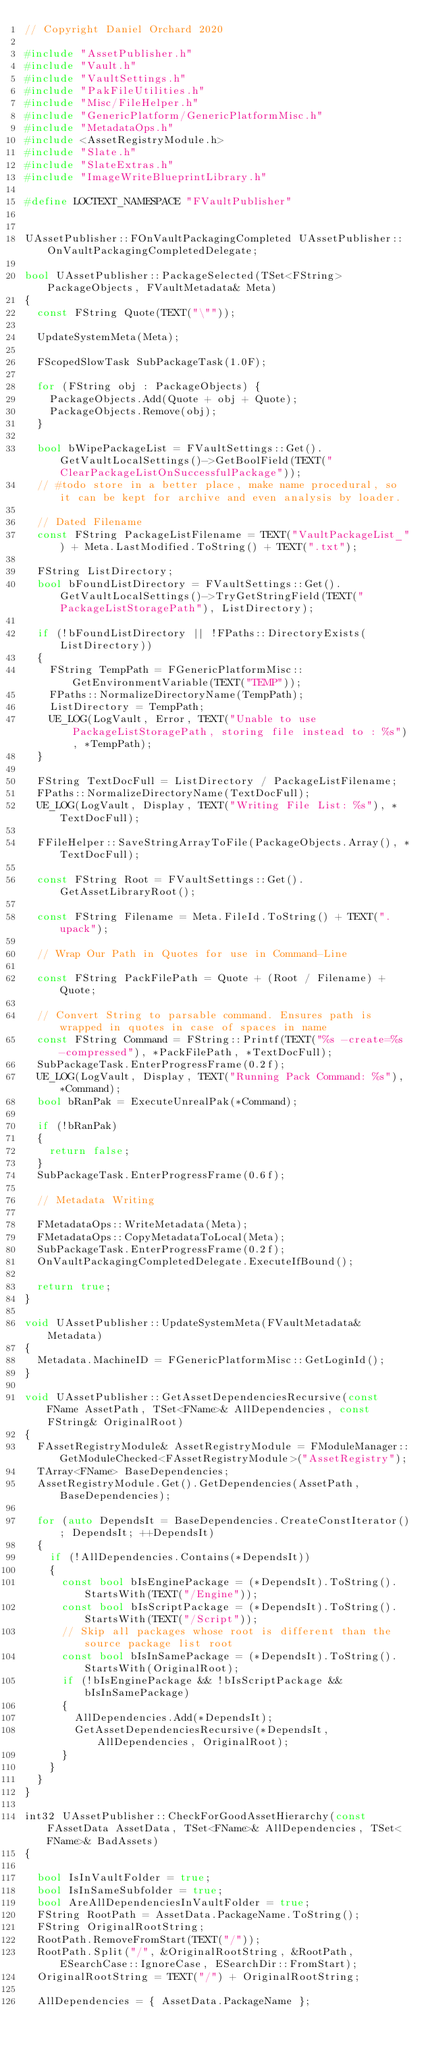<code> <loc_0><loc_0><loc_500><loc_500><_C++_>// Copyright Daniel Orchard 2020

#include "AssetPublisher.h"
#include "Vault.h"
#include "VaultSettings.h"
#include "PakFileUtilities.h"
#include "Misc/FileHelper.h"
#include "GenericPlatform/GenericPlatformMisc.h"
#include "MetadataOps.h"
#include <AssetRegistryModule.h>
#include "Slate.h"
#include "SlateExtras.h"
#include "ImageWriteBlueprintLibrary.h"

#define LOCTEXT_NAMESPACE "FVaultPublisher"


UAssetPublisher::FOnVaultPackagingCompleted UAssetPublisher::OnVaultPackagingCompletedDelegate;

bool UAssetPublisher::PackageSelected(TSet<FString> PackageObjects, FVaultMetadata& Meta)
{
	const FString Quote(TEXT("\""));

	UpdateSystemMeta(Meta);

	FScopedSlowTask SubPackageTask(1.0F);

	for (FString obj : PackageObjects) {
		PackageObjects.Add(Quote + obj + Quote);
		PackageObjects.Remove(obj);
	}

	bool bWipePackageList = FVaultSettings::Get().GetVaultLocalSettings()->GetBoolField(TEXT("ClearPackageListOnSuccessfulPackage"));
	// #todo store in a better place, make name procedural, so it can be kept for archive and even analysis by loader.

	// Dated Filename
	const FString PackageListFilename = TEXT("VaultPackageList_") + Meta.LastModified.ToString() + TEXT(".txt");

	FString ListDirectory;
	bool bFoundListDirectory = FVaultSettings::Get().GetVaultLocalSettings()->TryGetStringField(TEXT("PackageListStoragePath"), ListDirectory);

	if (!bFoundListDirectory || !FPaths::DirectoryExists(ListDirectory))
	{
		FString TempPath = FGenericPlatformMisc::GetEnvironmentVariable(TEXT("TEMP"));
		FPaths::NormalizeDirectoryName(TempPath);
		ListDirectory = TempPath;
		UE_LOG(LogVault, Error, TEXT("Unable to use PackageListStoragePath, storing file instead to : %s"), *TempPath);
	}

	FString TextDocFull = ListDirectory / PackageListFilename;
	FPaths::NormalizeDirectoryName(TextDocFull);
	UE_LOG(LogVault, Display, TEXT("Writing File List: %s"), *TextDocFull);
	
	FFileHelper::SaveStringArrayToFile(PackageObjects.Array(), *TextDocFull);
	
	const FString Root = FVaultSettings::Get().GetAssetLibraryRoot();
	
	const FString Filename = Meta.FileId.ToString() + TEXT(".upack");

	// Wrap Our Path in Quotes for use in Command-Line
	
	const FString PackFilePath = Quote + (Root / Filename) + Quote;
	
	// Convert String to parsable command. Ensures path is wrapped in quotes in case of spaces in name
	const FString Command = FString::Printf(TEXT("%s -create=%s -compressed"), *PackFilePath, *TextDocFull);
	SubPackageTask.EnterProgressFrame(0.2f);
	UE_LOG(LogVault, Display, TEXT("Running Pack Command: %s"), *Command);
	bool bRanPak = ExecuteUnrealPak(*Command);

	if (!bRanPak)
	{
		return false;
	}
	SubPackageTask.EnterProgressFrame(0.6f);

	// Metadata Writing

	FMetadataOps::WriteMetadata(Meta);
	FMetadataOps::CopyMetadataToLocal(Meta);
	SubPackageTask.EnterProgressFrame(0.2f);
	OnVaultPackagingCompletedDelegate.ExecuteIfBound();

	return true;
}

void UAssetPublisher::UpdateSystemMeta(FVaultMetadata& Metadata)
{
	Metadata.MachineID = FGenericPlatformMisc::GetLoginId();
}

void UAssetPublisher::GetAssetDependenciesRecursive(const FName AssetPath, TSet<FName>& AllDependencies, const FString& OriginalRoot)
{
	FAssetRegistryModule& AssetRegistryModule = FModuleManager::GetModuleChecked<FAssetRegistryModule>("AssetRegistry");
	TArray<FName> BaseDependencies;
	AssetRegistryModule.Get().GetDependencies(AssetPath, BaseDependencies);

	for (auto DependsIt = BaseDependencies.CreateConstIterator(); DependsIt; ++DependsIt)
	{
		if (!AllDependencies.Contains(*DependsIt))
		{
			const bool bIsEnginePackage = (*DependsIt).ToString().StartsWith(TEXT("/Engine"));
			const bool bIsScriptPackage = (*DependsIt).ToString().StartsWith(TEXT("/Script"));
			// Skip all packages whose root is different than the source package list root
			const bool bIsInSamePackage = (*DependsIt).ToString().StartsWith(OriginalRoot);
			if (!bIsEnginePackage && !bIsScriptPackage && bIsInSamePackage)
			{
				AllDependencies.Add(*DependsIt);
				GetAssetDependenciesRecursive(*DependsIt, AllDependencies, OriginalRoot);
			}
		}
	}
}

int32 UAssetPublisher::CheckForGoodAssetHierarchy(const FAssetData AssetData, TSet<FName>& AllDependencies, TSet<FName>& BadAssets)
{
	
	bool IsInVaultFolder = true;
	bool IsInSameSubfolder = true;
	bool AreAllDependenciesInVaultFolder = true;
	FString RootPath = AssetData.PackageName.ToString();
	FString OriginalRootString;
	RootPath.RemoveFromStart(TEXT("/"));
	RootPath.Split("/", &OriginalRootString, &RootPath, ESearchCase::IgnoreCase, ESearchDir::FromStart);
	OriginalRootString = TEXT("/") + OriginalRootString;

	AllDependencies = { AssetData.PackageName };</code> 